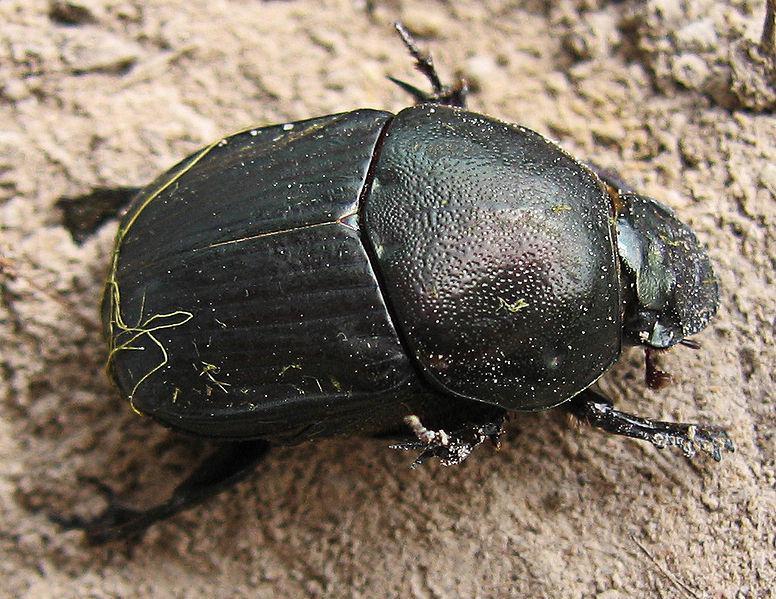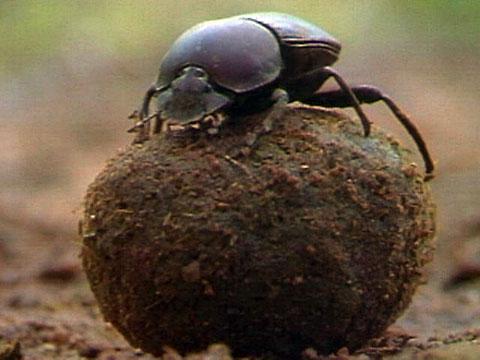The first image is the image on the left, the second image is the image on the right. Examine the images to the left and right. Is the description "Only one beetle is on a ball of dirt." accurate? Answer yes or no. Yes. The first image is the image on the left, the second image is the image on the right. Examine the images to the left and right. Is the description "Each image features a beetle in contact with a dung ball." accurate? Answer yes or no. No. 